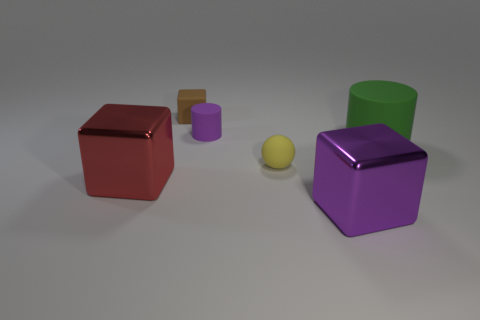Add 3 tiny gray spheres. How many objects exist? 9 Subtract all purple cubes. How many cubes are left? 2 Subtract all purple blocks. How many blocks are left? 2 Subtract all cylinders. How many objects are left? 4 Subtract all brown balls. Subtract all red cylinders. How many balls are left? 1 Subtract all brown spheres. How many yellow cylinders are left? 0 Subtract all yellow rubber objects. Subtract all cylinders. How many objects are left? 3 Add 2 large green matte things. How many large green matte things are left? 3 Add 3 yellow matte blocks. How many yellow matte blocks exist? 3 Subtract 0 red spheres. How many objects are left? 6 